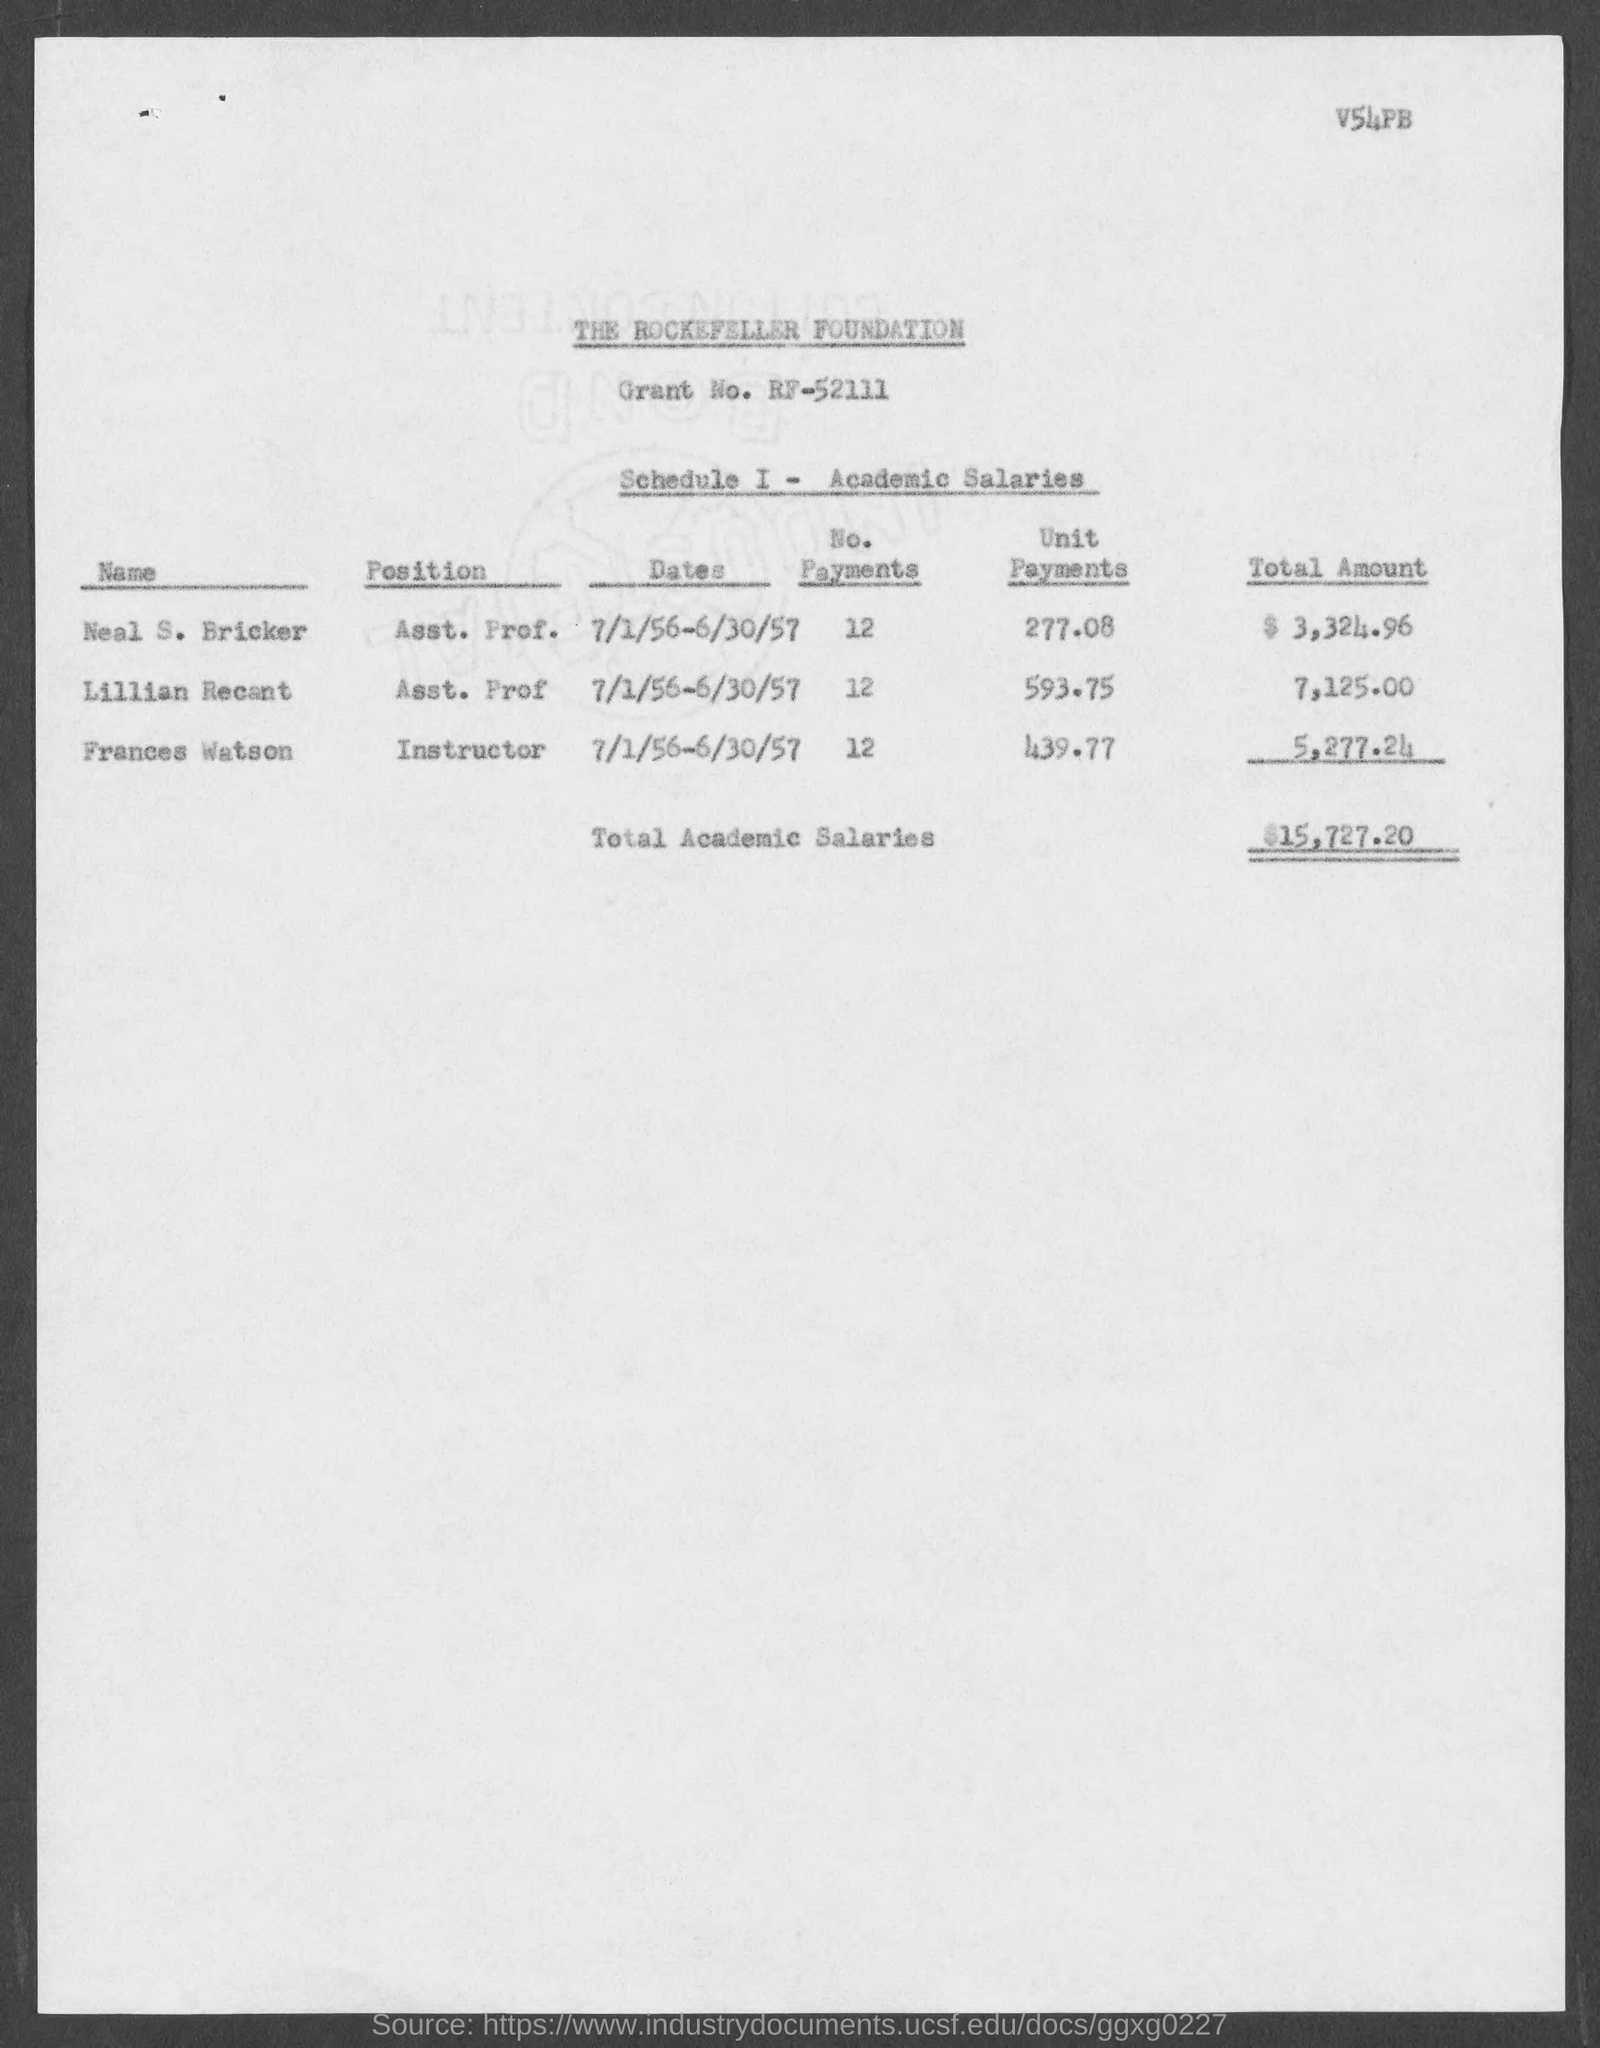Point out several critical features in this image. The total academic salaries are 15,727.20. Neal S. Bricker holds the position of Assistant Professor. Neal S. Bricker has 12 payments. The unit payments for Lillian Recent are 593.75. There are 12 payments for Lillian Recent. 